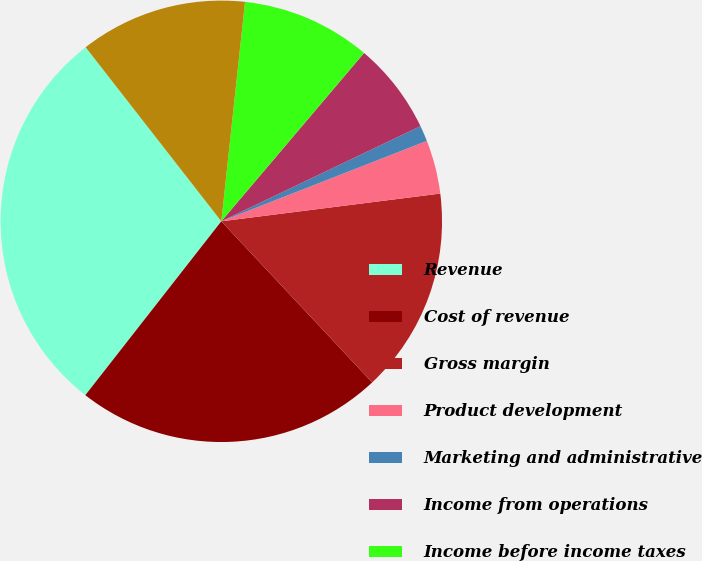Convert chart to OTSL. <chart><loc_0><loc_0><loc_500><loc_500><pie_chart><fcel>Revenue<fcel>Cost of revenue<fcel>Gross margin<fcel>Product development<fcel>Marketing and administrative<fcel>Income from operations<fcel>Income before income taxes<fcel>Net income<nl><fcel>28.9%<fcel>22.54%<fcel>15.03%<fcel>3.93%<fcel>1.16%<fcel>6.71%<fcel>9.48%<fcel>12.25%<nl></chart> 